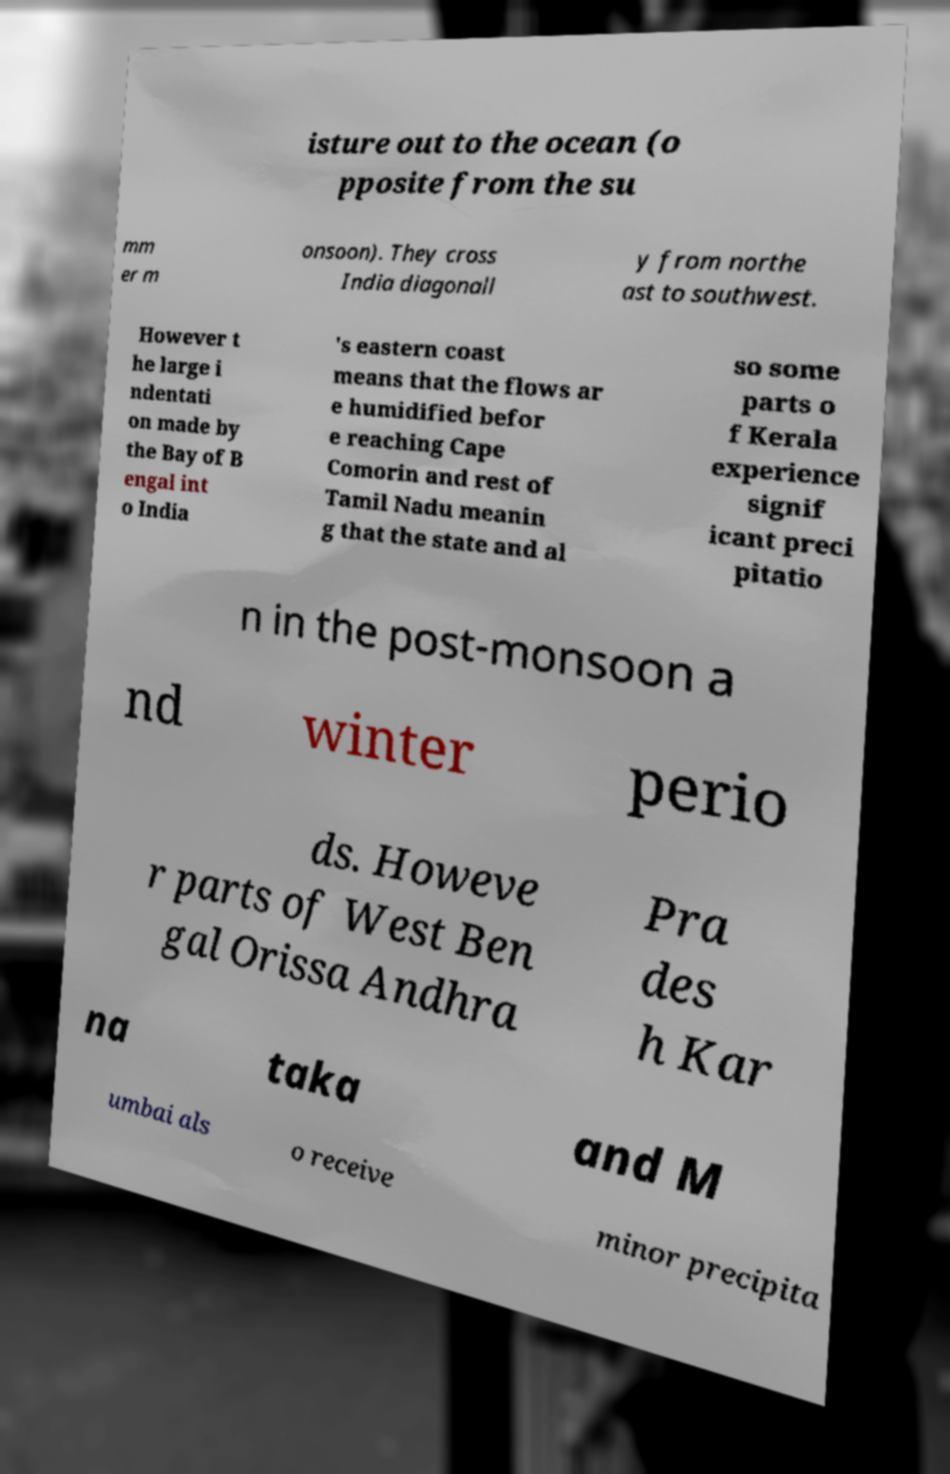For documentation purposes, I need the text within this image transcribed. Could you provide that? isture out to the ocean (o pposite from the su mm er m onsoon). They cross India diagonall y from northe ast to southwest. However t he large i ndentati on made by the Bay of B engal int o India 's eastern coast means that the flows ar e humidified befor e reaching Cape Comorin and rest of Tamil Nadu meanin g that the state and al so some parts o f Kerala experience signif icant preci pitatio n in the post-monsoon a nd winter perio ds. Howeve r parts of West Ben gal Orissa Andhra Pra des h Kar na taka and M umbai als o receive minor precipita 